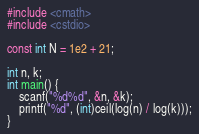<code> <loc_0><loc_0><loc_500><loc_500><_C++_>#include <cmath>
#include <cstdio>

const int N = 1e2 + 21;

int n, k;
int main() {
	scanf("%d%d", &n, &k);
	printf("%d", (int)ceil(log(n) / log(k)));
}</code> 